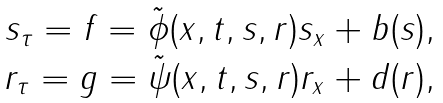Convert formula to latex. <formula><loc_0><loc_0><loc_500><loc_500>\begin{array} { c } s _ { \tau } = f = \tilde { \phi } ( x , t , s , r ) s _ { x } + b ( s ) , \\ r _ { \tau } = g = \tilde { \psi } ( x , t , s , r ) r _ { x } + d ( r ) , \end{array}</formula> 